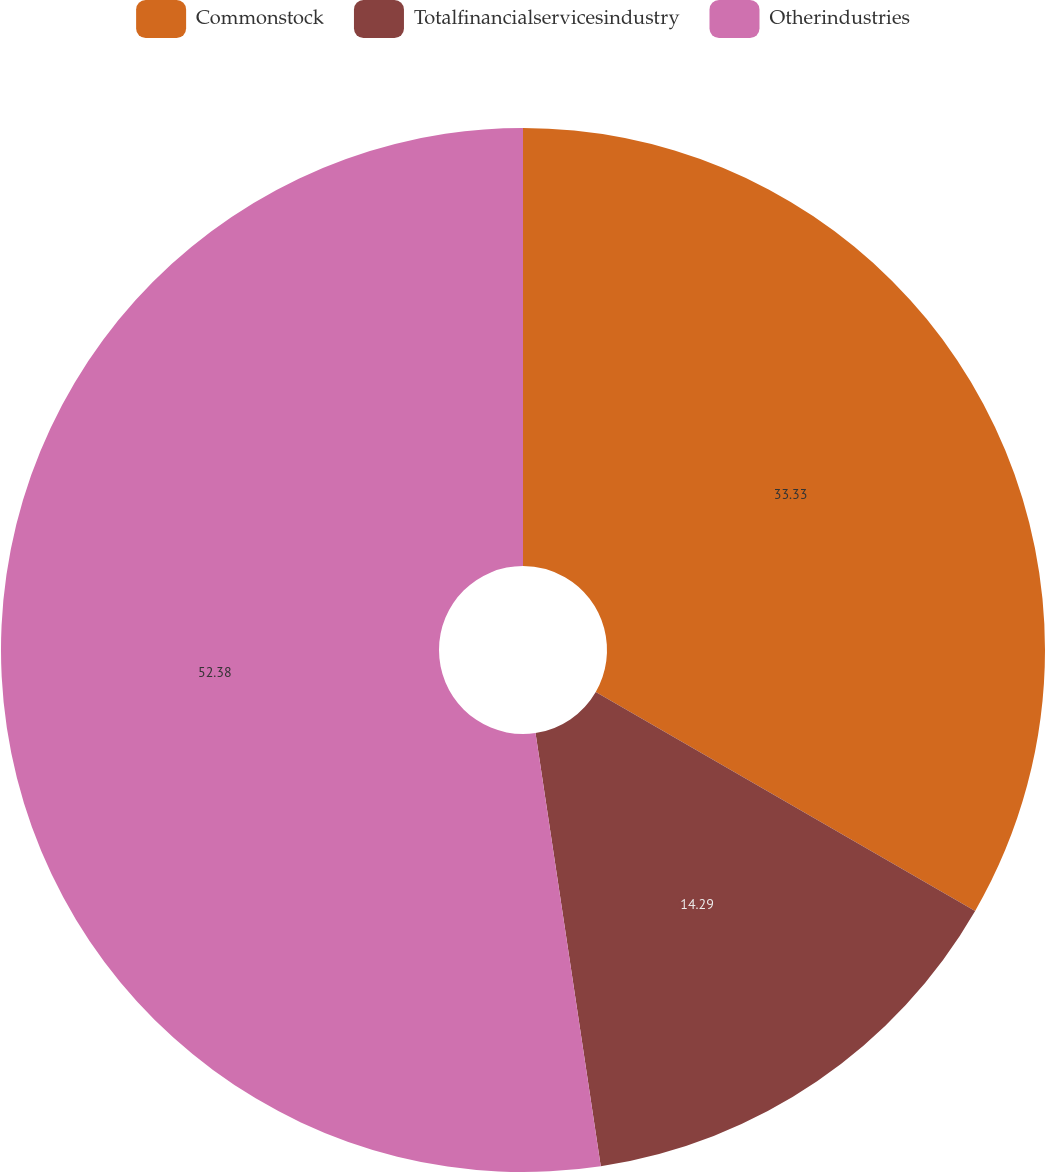Convert chart to OTSL. <chart><loc_0><loc_0><loc_500><loc_500><pie_chart><fcel>Commonstock<fcel>Totalfinancialservicesindustry<fcel>Otherindustries<nl><fcel>33.33%<fcel>14.29%<fcel>52.38%<nl></chart> 